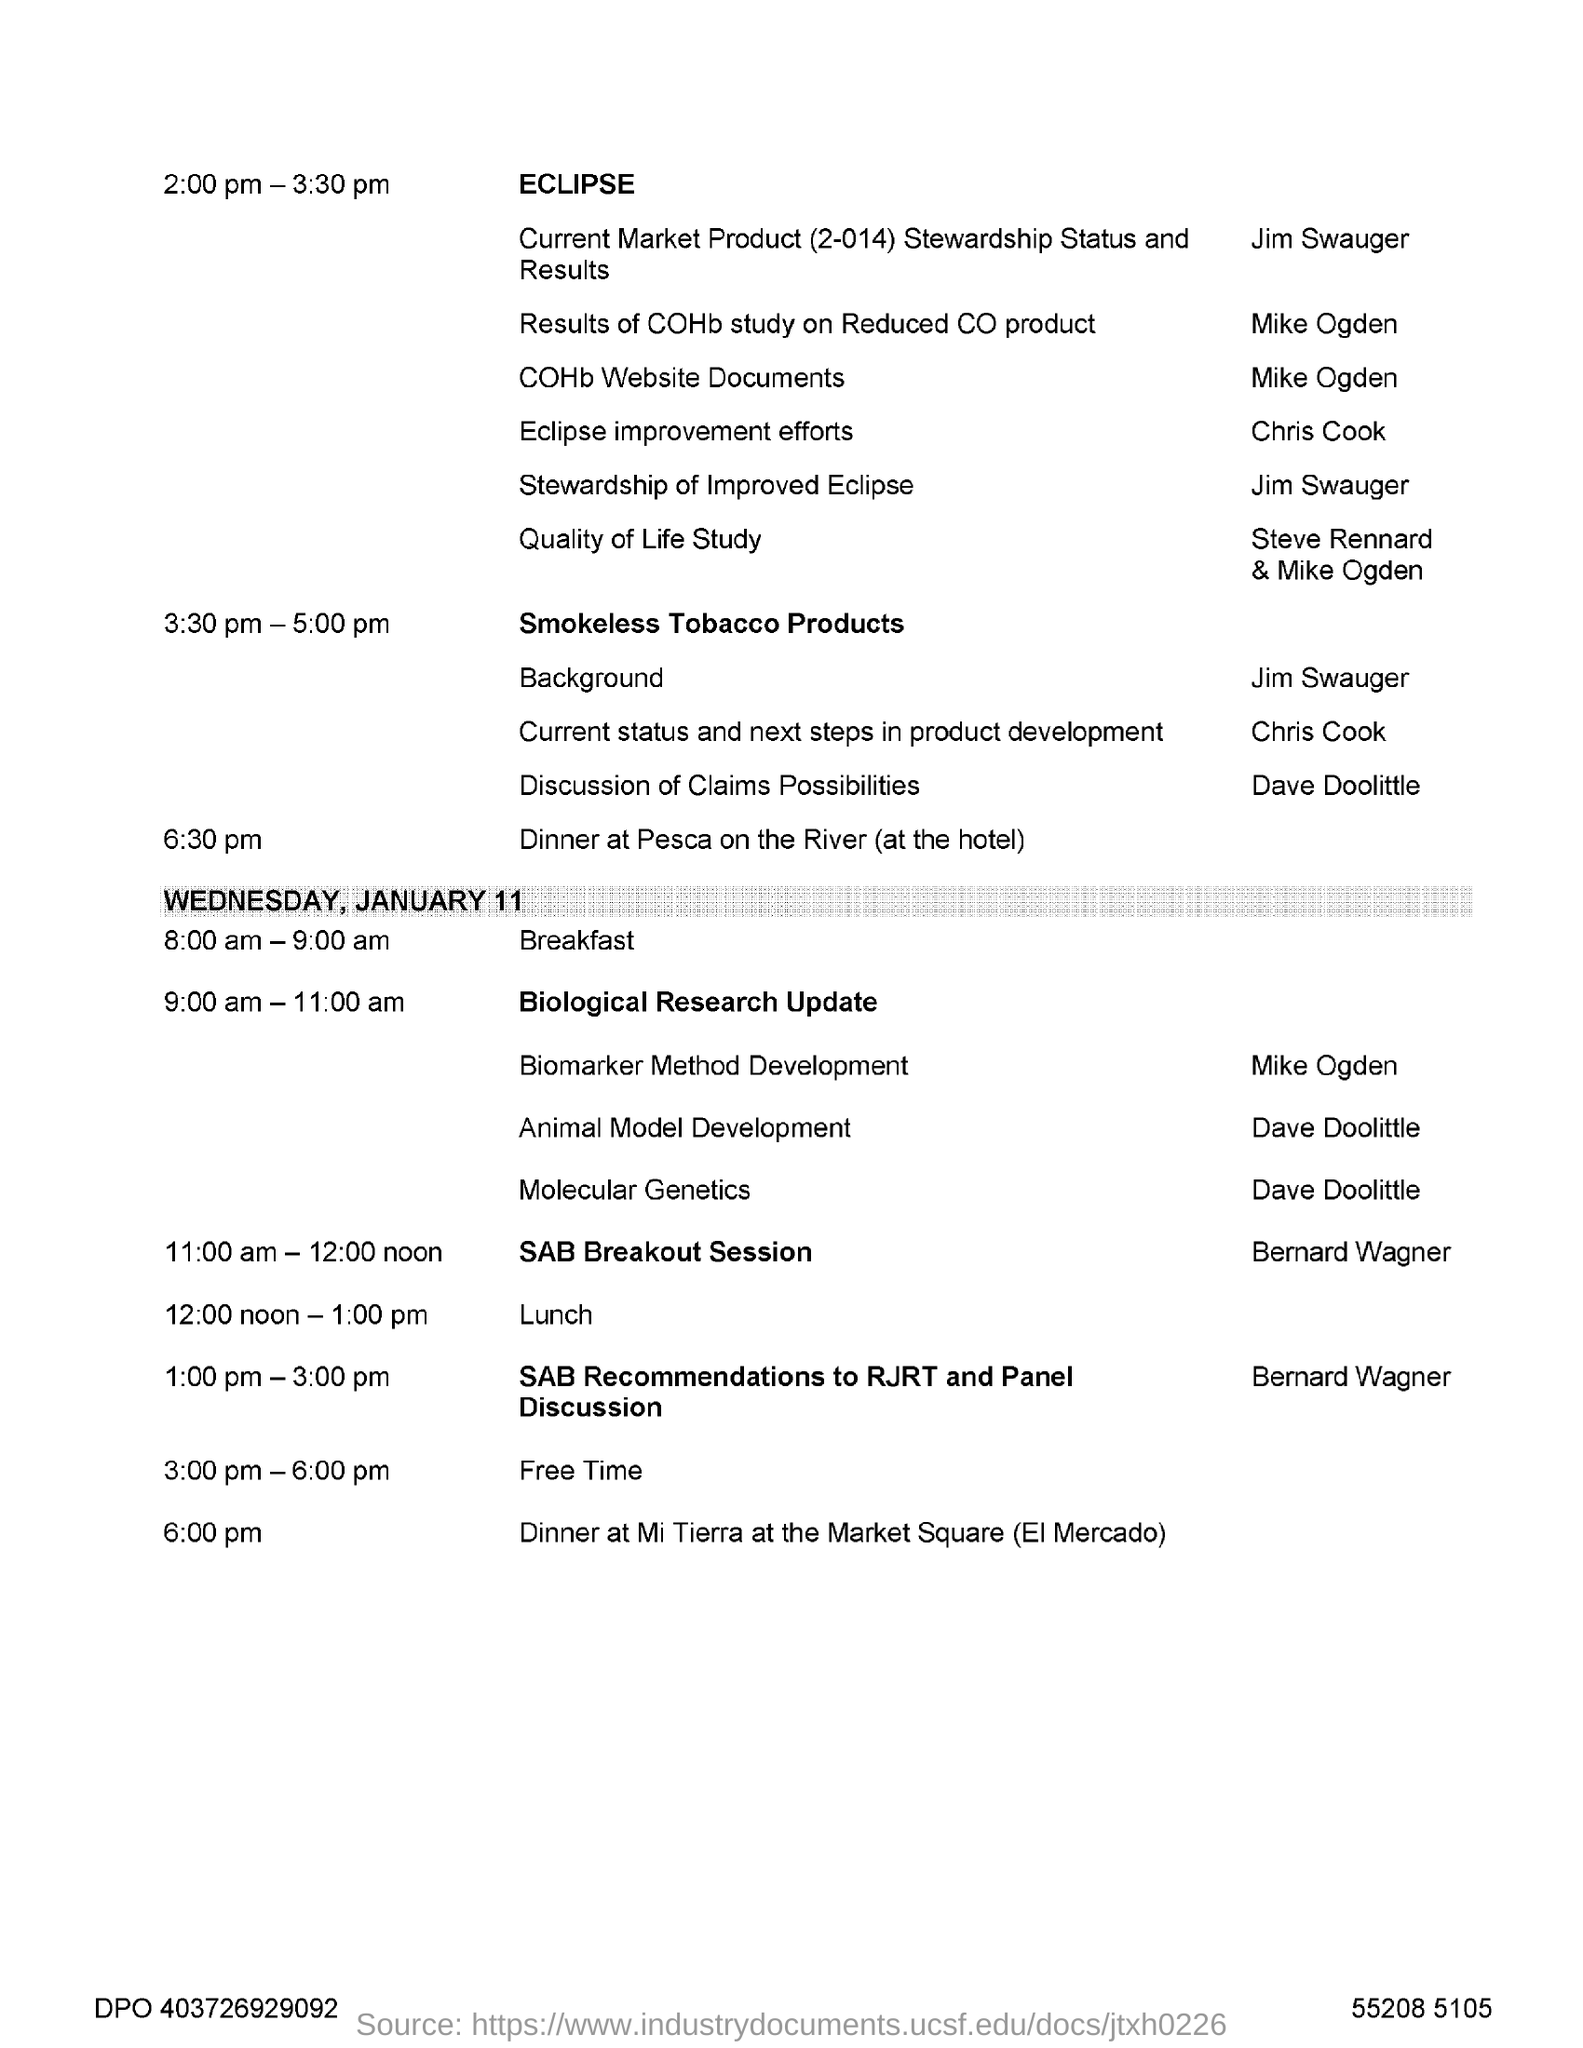What time is the lunch scheduled on Wednesday, January 11?
Keep it short and to the point. 12:00 noon - 1:00 pm. When is dinner at Pesca on the River?
Keep it short and to the point. 6.30 pm. 